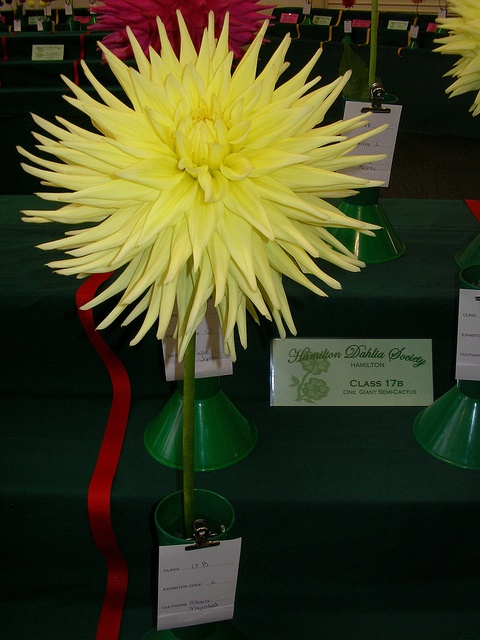Describe the objects in this image and their specific colors. I can see vase in black, darkgreen, and teal tones, vase in black, darkgreen, and teal tones, and vase in black, darkgreen, and gray tones in this image. 